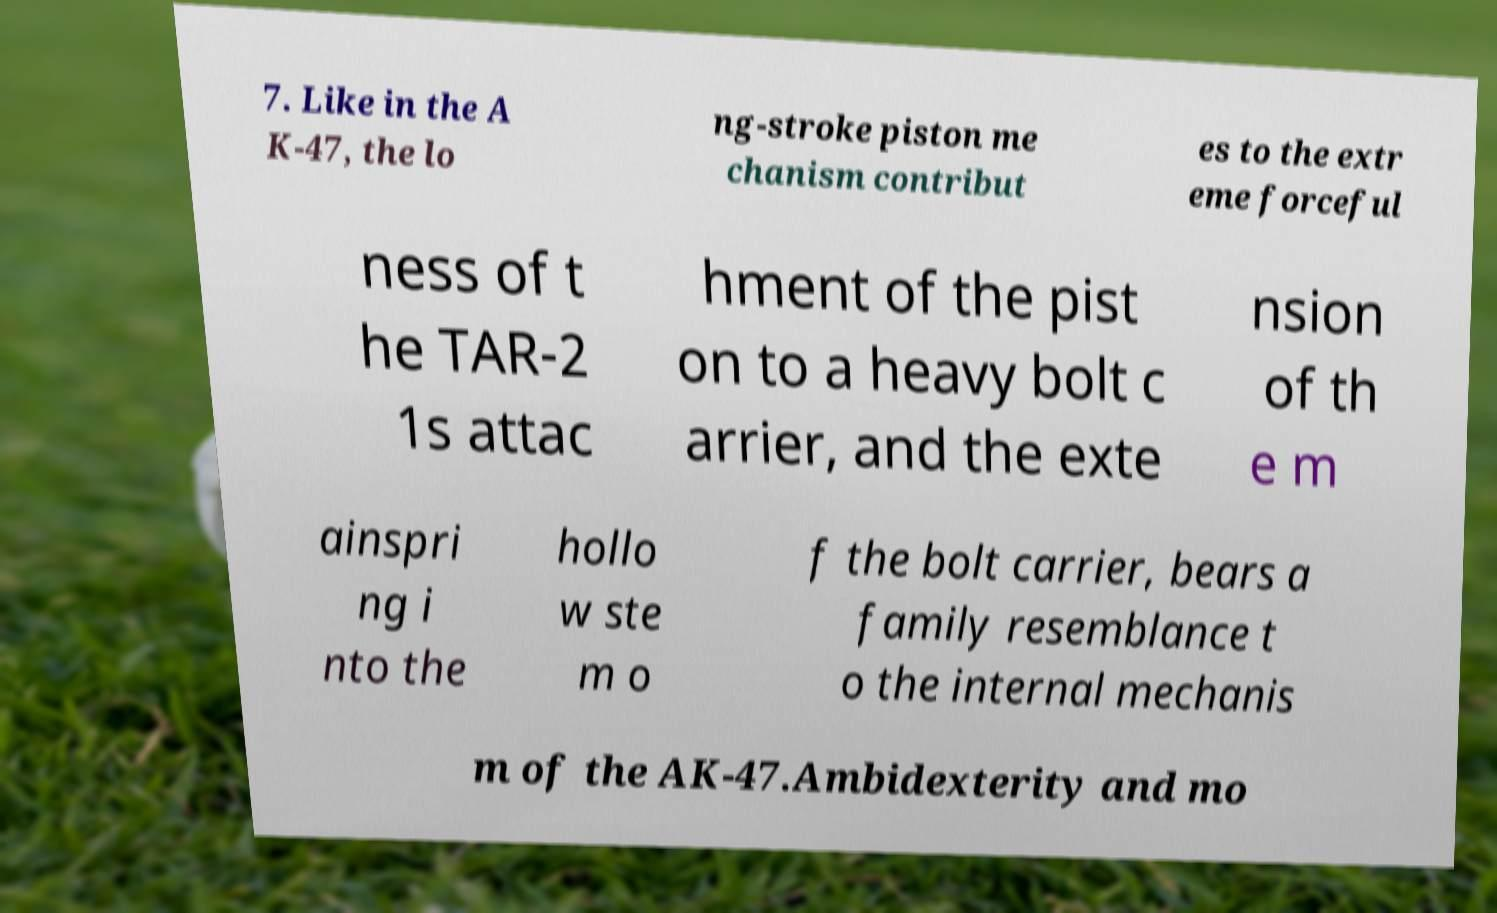Please identify and transcribe the text found in this image. 7. Like in the A K-47, the lo ng-stroke piston me chanism contribut es to the extr eme forceful ness of t he TAR-2 1s attac hment of the pist on to a heavy bolt c arrier, and the exte nsion of th e m ainspri ng i nto the hollo w ste m o f the bolt carrier, bears a family resemblance t o the internal mechanis m of the AK-47.Ambidexterity and mo 